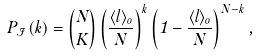Convert formula to latex. <formula><loc_0><loc_0><loc_500><loc_500>P _ { \mathcal { I } } ( k ) = \binom { N } { K } \left ( \frac { \langle l \rangle _ { o } } { N } \right ) ^ { k } \left ( 1 - \frac { \langle l \rangle _ { o } } { N } \right ) ^ { N - k } ,</formula> 